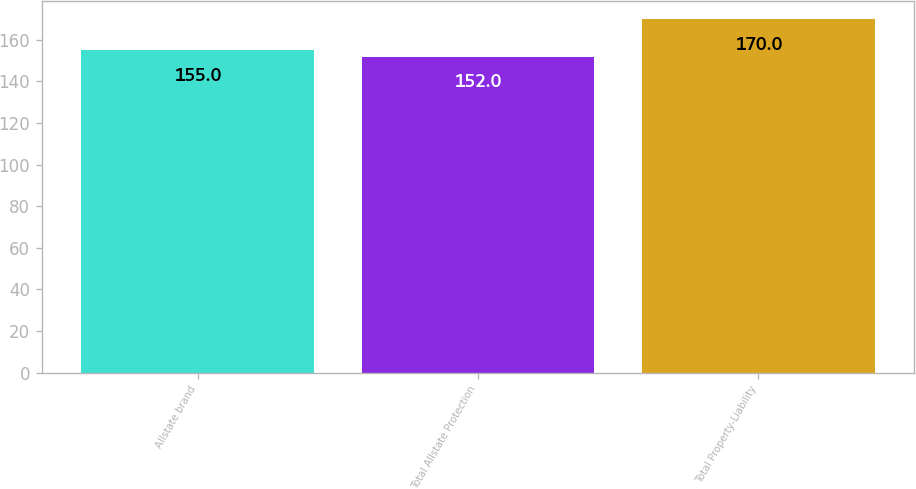Convert chart to OTSL. <chart><loc_0><loc_0><loc_500><loc_500><bar_chart><fcel>Allstate brand<fcel>Total Allstate Protection<fcel>Total Property-Liability<nl><fcel>155<fcel>152<fcel>170<nl></chart> 